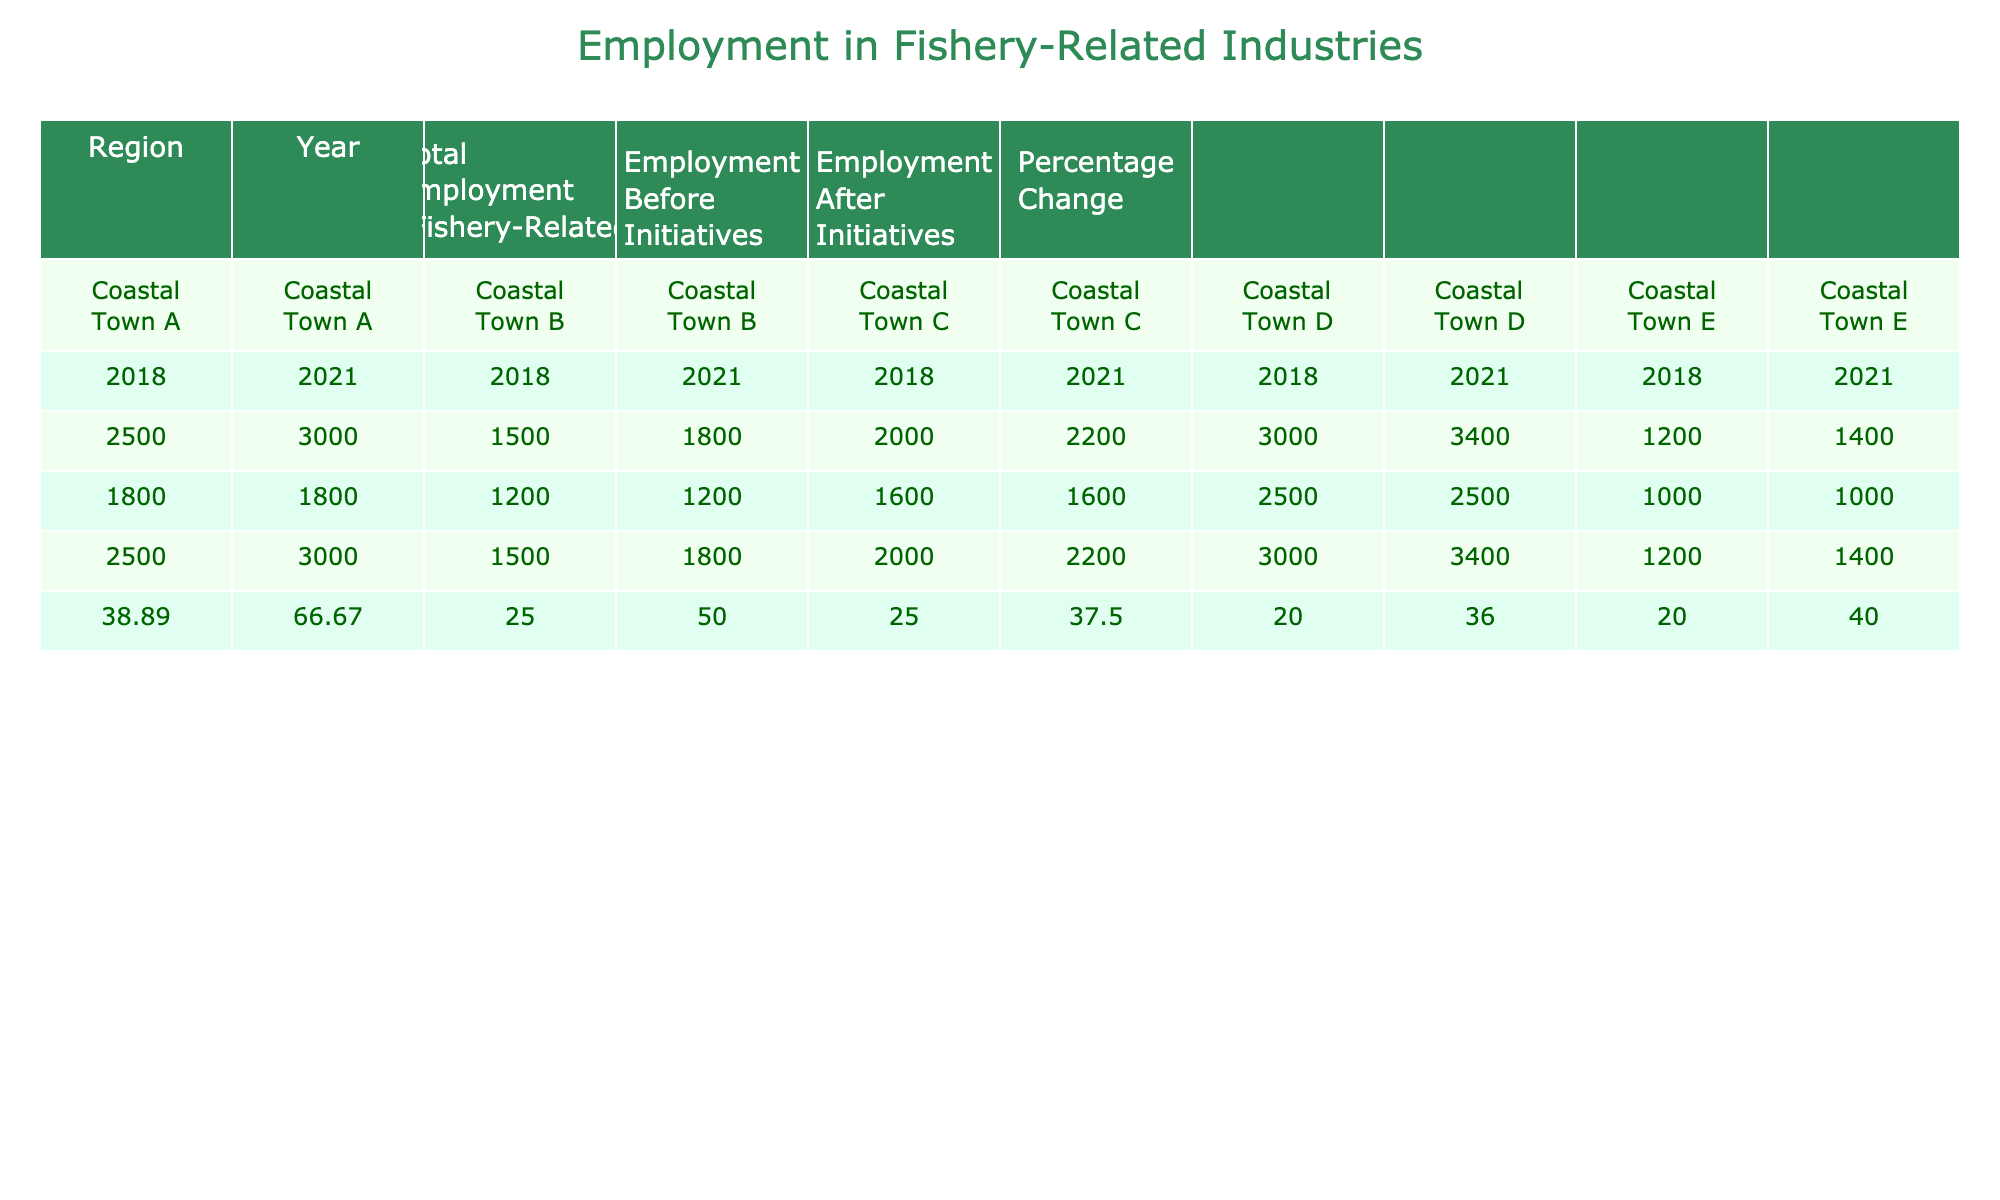What was the total employment in Coastal Town A in 2021? The table shows that in Coastal Town A, the total employment in 2021 is listed as 3000.
Answer: 3000 What is the percentage change in employment for Coastal Town B from 2018 to 2021? For Coastal Town B, employment in 2018 is 1500 and in 2021 is 1800. The percentage change is calculated as ((1800 - 1500) / 1500) * 100 = 20%.
Answer: 20% Did Coastal Town E see an increase in total employment after the economic initiatives? Yes, the total employment in Coastal Town E increased from 1200 in 2018 to 1400 in 2021, indicating a positive increase after the initiatives.
Answer: Yes What is the average total employment across all towns in 2021? To find the average total employment in 2021, sum the total employment for all towns (3000 + 1800 + 2200 + 3400 + 1400 = 11800) and divide by the number of towns (5), resulting in an average of 11800 / 5 = 2360.
Answer: 2360 Which coastal town had the highest percentage change in employment after the initiatives? By reviewing the percentage changes for all towns in 2021, Coastal Town A shows a 66.67% increase, which is the highest in comparison to the others.
Answer: Coastal Town A What was the total number of employed individuals before the initiatives in Coastal Town D? According to the table, the employment before initiatives in Coastal Town D is listed as 2500.
Answer: 2500 Is it true that all coastal towns experienced a percentage increase in employment after the initiatives? Yes, all listed coastal towns show a positive percentage change indicating that they all experienced an increase in employment after the initiatives.
Answer: Yes What is the difference in employment after the initiatives between Coastal Town C and Coastal Town D? Employment after initiatives in Coastal Town C is 2200 and in Coastal Town D is 3400. The difference is 3400 - 2200 = 1200.
Answer: 1200 What percentage of employment in Coastal Town E was there before the initiatives compared to after? In Coastal Town E, employment before initiatives was 1000 and after was 1400. The percentage before is (1000 / 1400) * 100 = 71.43%.
Answer: 71.43% 